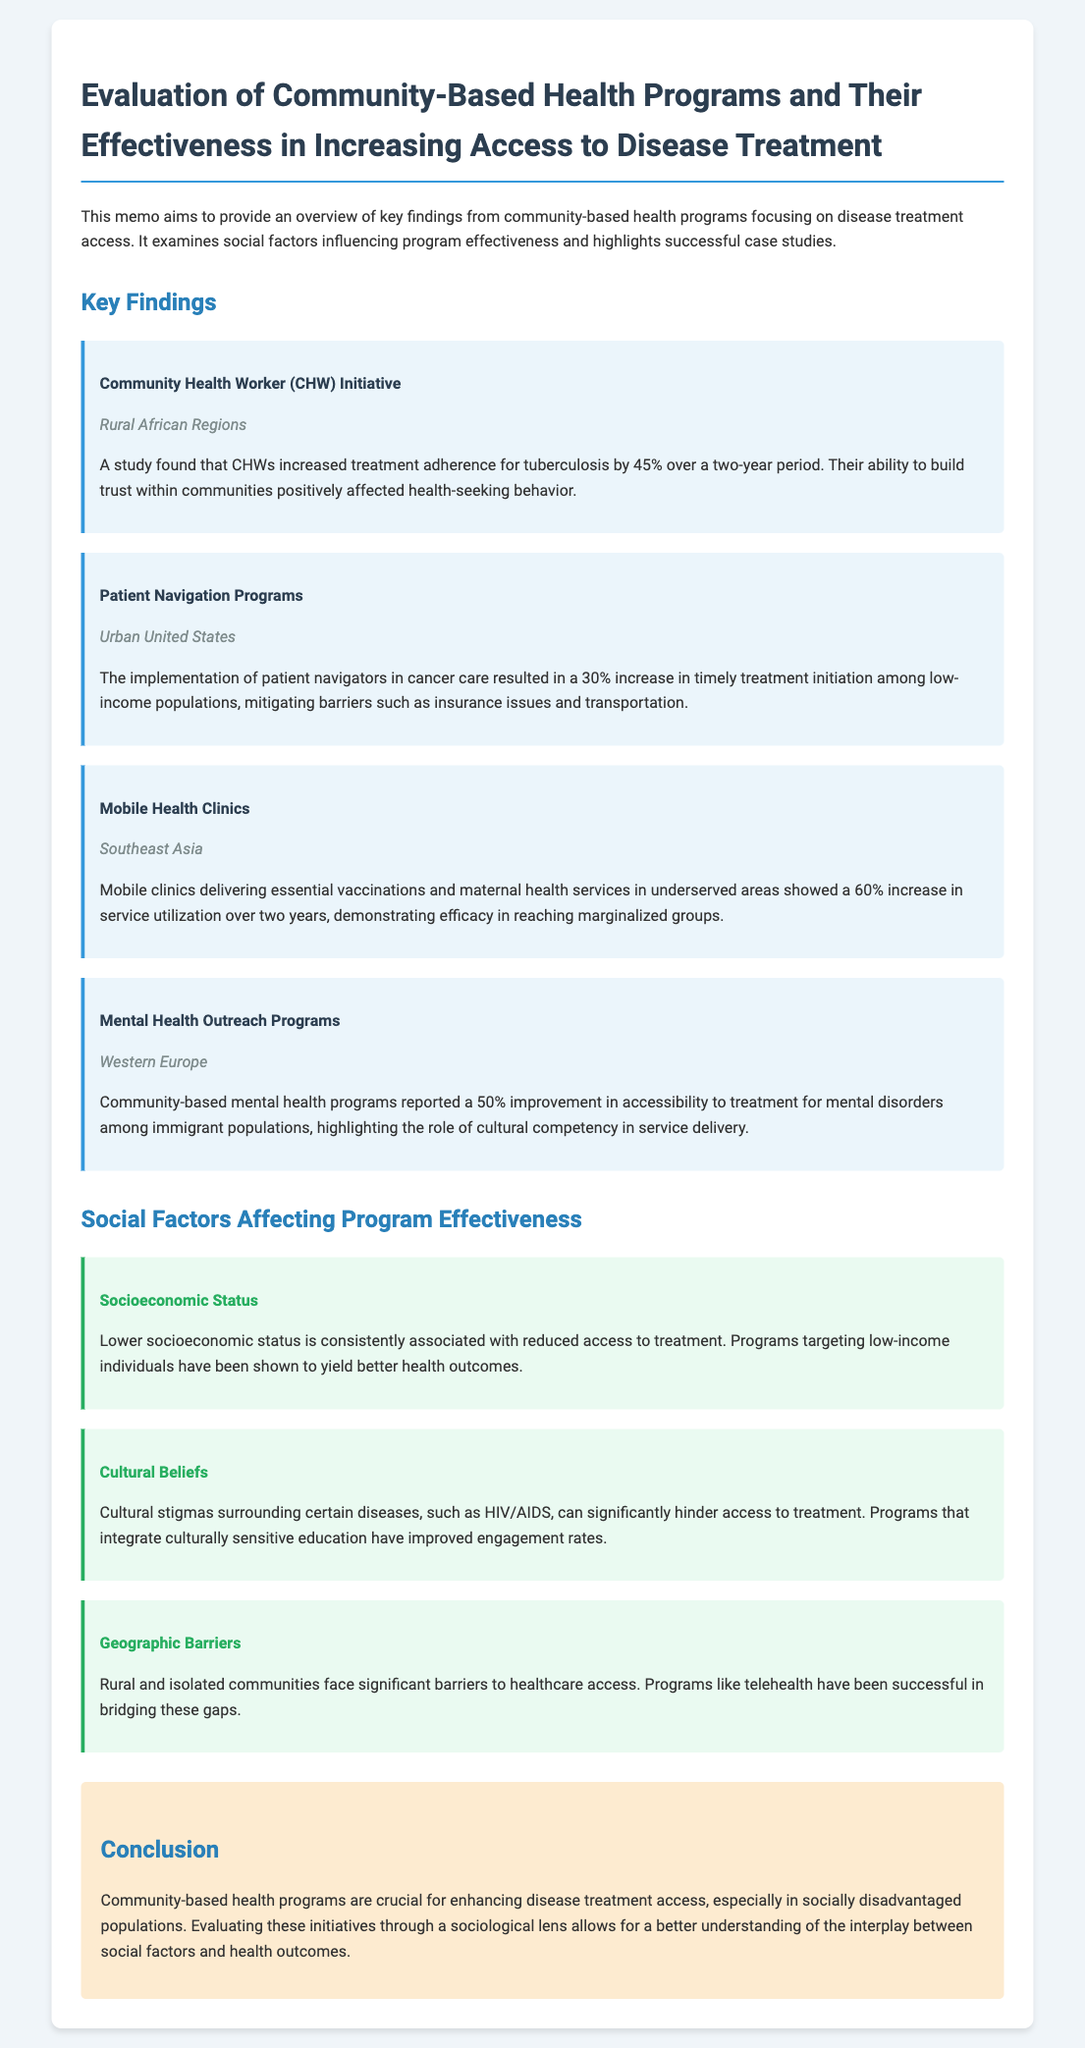What program increased tuberculosis treatment adherence? The program that increased tuberculosis treatment adherence is the Community Health Worker (CHW) Initiative, which was effective in rural African regions.
Answer: Community Health Worker (CHW) Initiative What percentage increase in timely cancer treatment initiation was achieved through patient navigators? The implementation of patient navigators in cancer care resulted in a 30% increase in timely treatment initiation among low-income populations.
Answer: 30% Which region saw a 60% increase in service utilization due to mobile health clinics? The Southeast Asia region showed a 60% increase in service utilization due to mobile health clinics delivering essential vaccinations and maternal health services.
Answer: Southeast Asia What social factor is linked with reduced access to treatment? Lower socioeconomic status is consistently associated with reduced access to treatment.
Answer: Socioeconomic Status What was the improvement percentage in mental health treatment accessibility for immigrant populations? Community-based mental health programs reported a 50% improvement in accessibility to treatment for mental disorders among immigrant populations.
Answer: 50% What is one cultural barrier to disease treatment access mentioned? Cultural stigmas surrounding certain diseases, such as HIV/AIDS, can significantly hinder access to treatment.
Answer: Cultural stigmas What community factor was highlighted as essential for the CHW Initiative's success? The ability to build trust within communities positively affected health-seeking behavior in the CHW Initiative.
Answer: Trust What is the main purpose of the memo? The main purpose of the memo is to provide an overview of key findings from community-based health programs focusing on disease treatment access.
Answer: Overview of key findings 